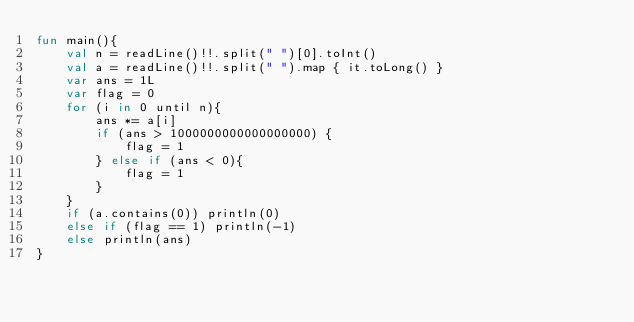Convert code to text. <code><loc_0><loc_0><loc_500><loc_500><_Kotlin_>fun main(){
    val n = readLine()!!.split(" ")[0].toInt()
    val a = readLine()!!.split(" ").map { it.toLong() }
    var ans = 1L
    var flag = 0
    for (i in 0 until n){
        ans *= a[i]
        if (ans > 1000000000000000000) {
            flag = 1
        } else if (ans < 0){
            flag = 1
        }
    }
    if (a.contains(0)) println(0)
    else if (flag == 1) println(-1)
    else println(ans)
}
</code> 